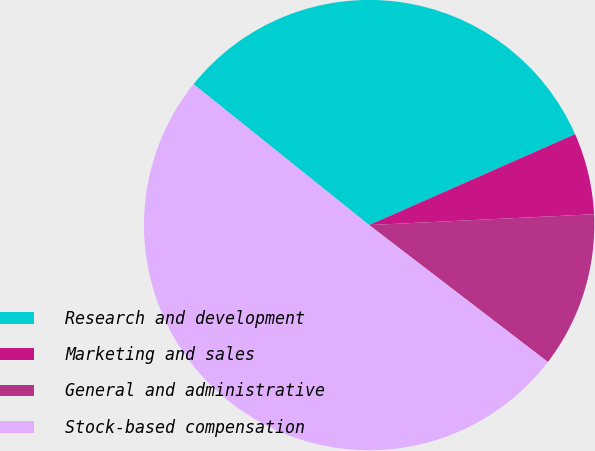Convert chart. <chart><loc_0><loc_0><loc_500><loc_500><pie_chart><fcel>Research and development<fcel>Marketing and sales<fcel>General and administrative<fcel>Stock-based compensation<nl><fcel>32.62%<fcel>5.85%<fcel>11.17%<fcel>50.35%<nl></chart> 